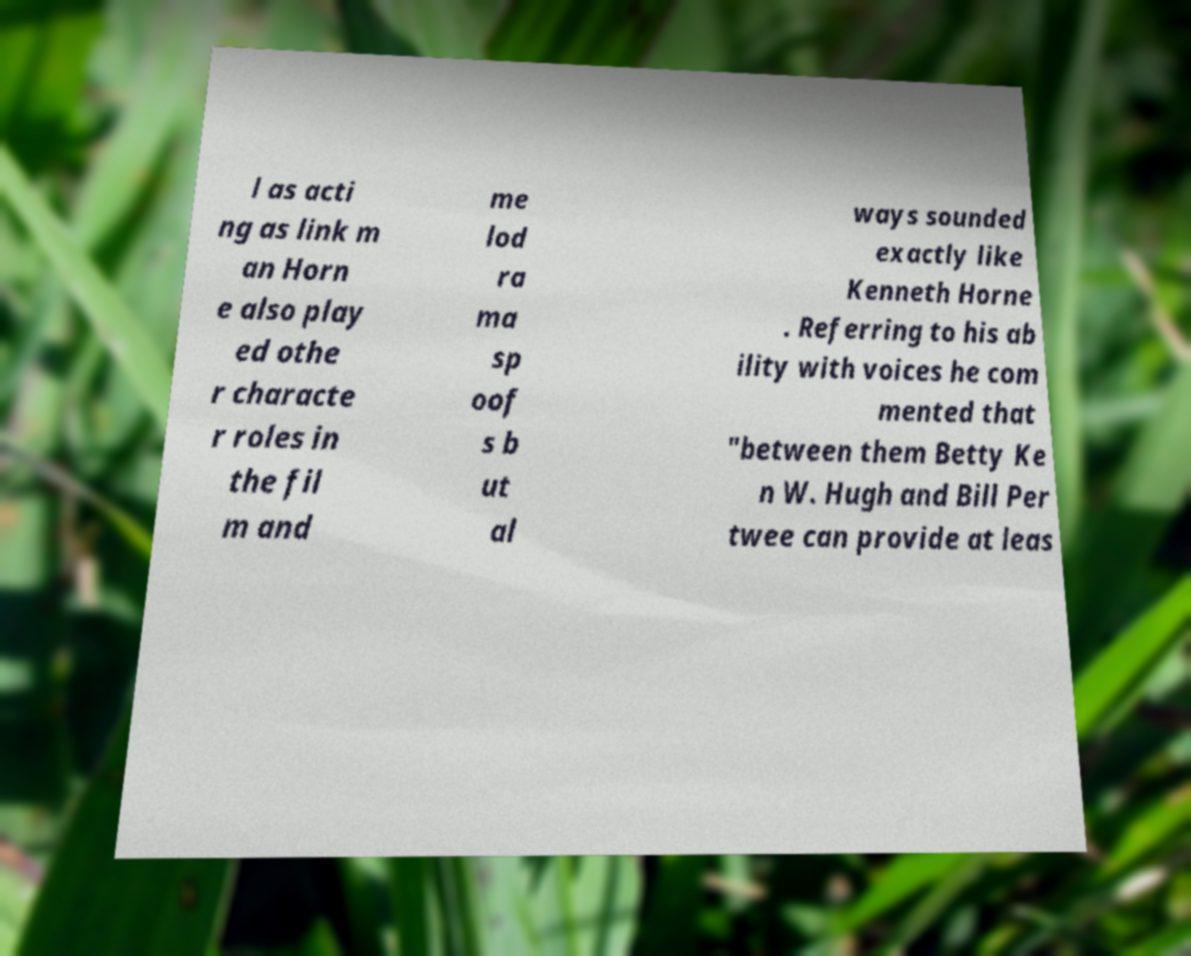There's text embedded in this image that I need extracted. Can you transcribe it verbatim? l as acti ng as link m an Horn e also play ed othe r characte r roles in the fil m and me lod ra ma sp oof s b ut al ways sounded exactly like Kenneth Horne . Referring to his ab ility with voices he com mented that "between them Betty Ke n W. Hugh and Bill Per twee can provide at leas 